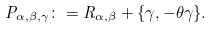Convert formula to latex. <formula><loc_0><loc_0><loc_500><loc_500>P _ { \alpha , \beta , \gamma } \colon = R _ { \alpha , \beta } + \{ \gamma , - \theta \gamma \} .</formula> 